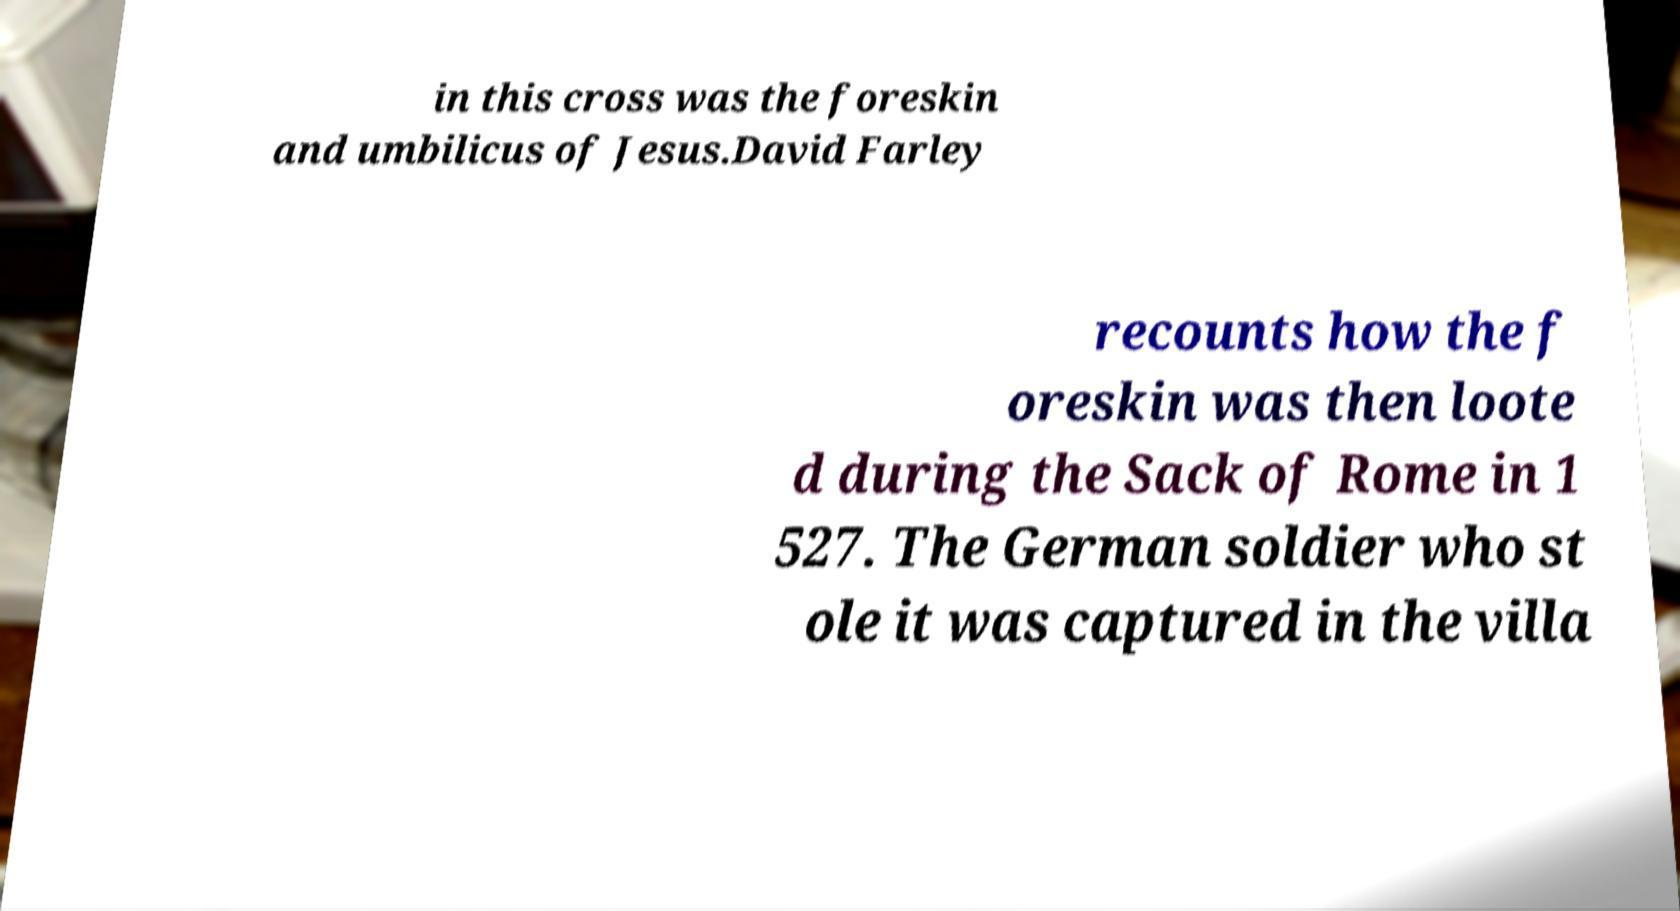Please identify and transcribe the text found in this image. in this cross was the foreskin and umbilicus of Jesus.David Farley recounts how the f oreskin was then loote d during the Sack of Rome in 1 527. The German soldier who st ole it was captured in the villa 